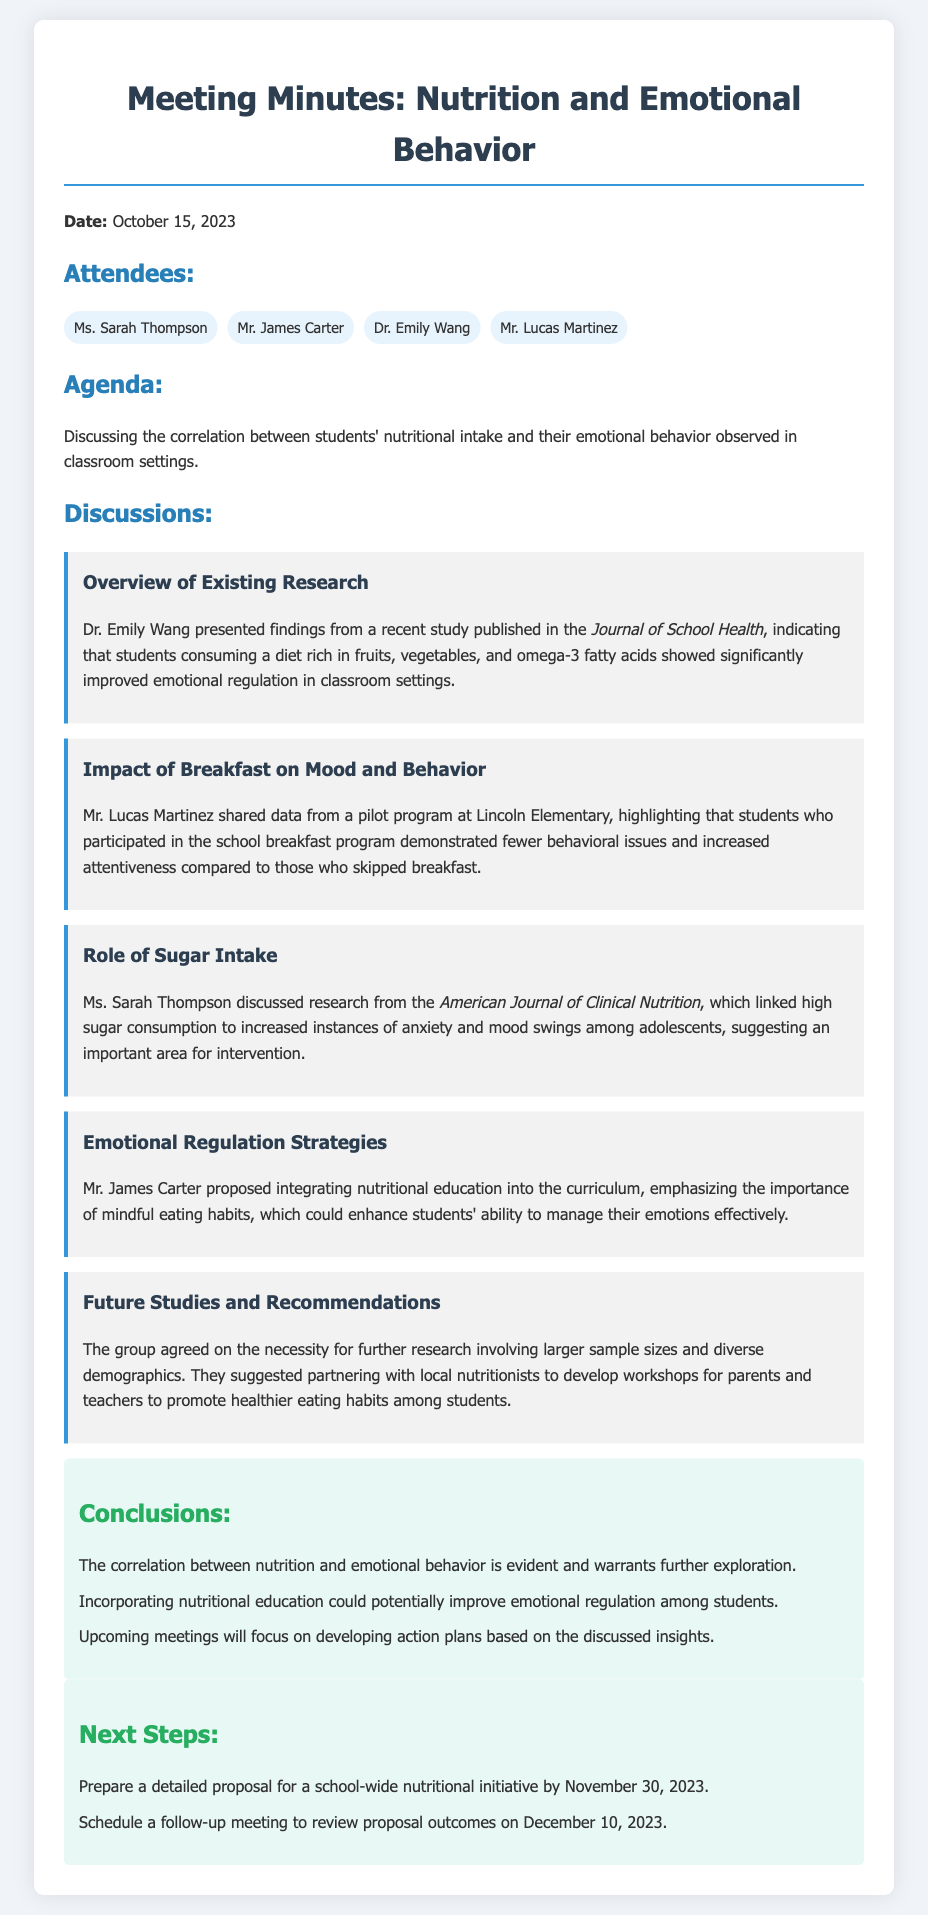What is the date of the meeting? The date of the meeting is listed in the header section of the document as October 15, 2023.
Answer: October 15, 2023 Who presented the findings from the recent study? The findings from the recent study were presented by Dr. Emily Wang during the discussions.
Answer: Dr. Emily Wang What did the pilot program at Lincoln Elementary highlight? The pilot program highlighted that students who participated in the school breakfast program demonstrated fewer behavioral issues and increased attentiveness.
Answer: Fewer behavioral issues and increased attentiveness Which topic discussed links high sugar consumption to mood swings? The topic discussing the impact of sugar intake and mood swings was presented by Ms. Sarah Thompson.
Answer: Ms. Sarah Thompson How many attendees were present at the meeting? The list of attendees shows a total of four people present at the meeting.
Answer: Four What is one of the conclusions drawn from the meeting? The conclusion stated that the correlation between nutrition and emotional behavior is evident and warrants further exploration.
Answer: Correlation between nutrition and emotional behavior is evident When is the follow-up meeting scheduled? The follow-up meeting is scheduled for December 10, 2023, as mentioned in the next steps section.
Answer: December 10, 2023 What type of educational integration did Mr. James Carter propose? Mr. James Carter proposed integrating nutritional education into the curriculum to enhance emotional regulation among students.
Answer: Nutritional education 